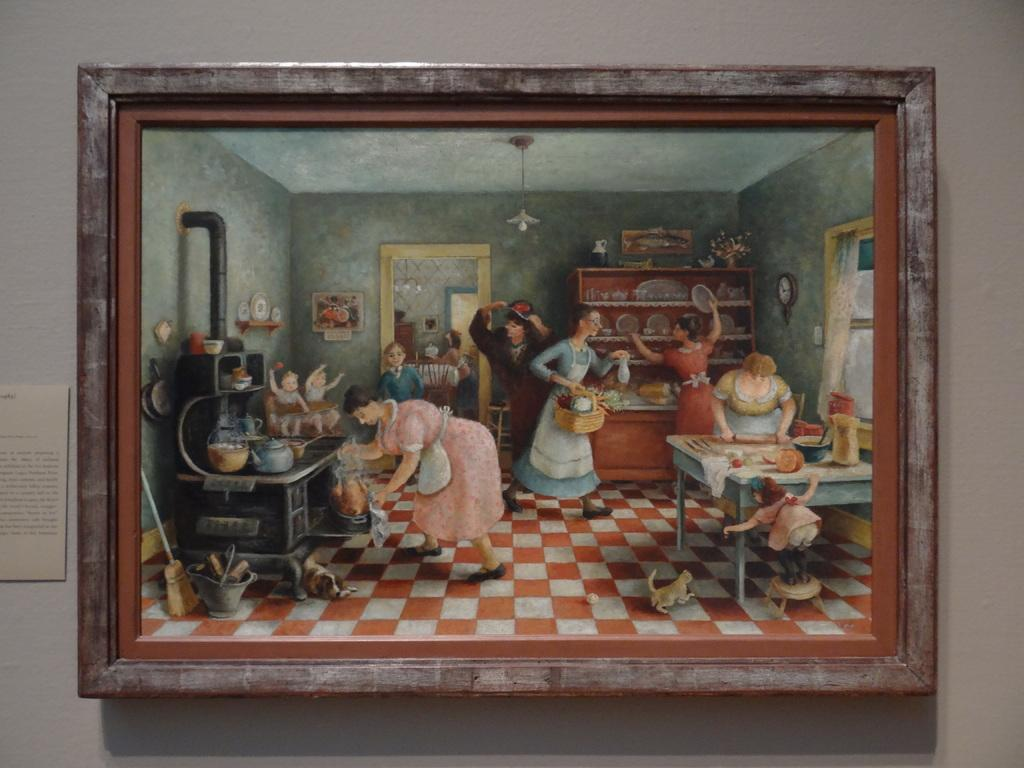What is hanging on the wall in the image? There is a photo frame of a painting on the wall. What is the subject of the painting? The painting depicts a room with multiple women. What are the women in the painting doing? The women in the painting are doing different works. What type of waste is visible in the painting? There is no waste visible in the painting; it depicts a room with multiple women doing different works. 